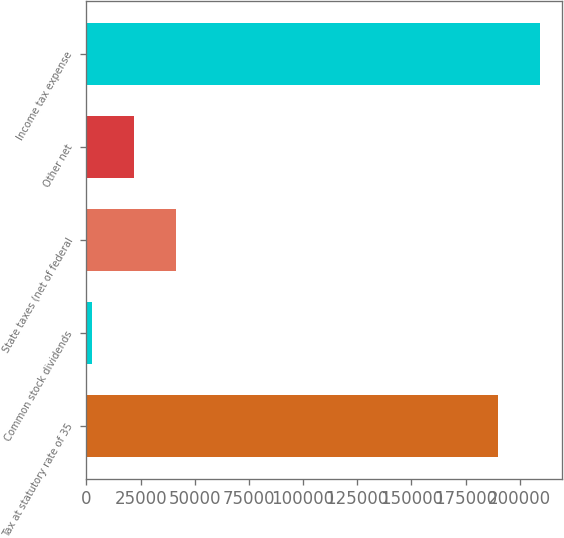Convert chart. <chart><loc_0><loc_0><loc_500><loc_500><bar_chart><fcel>Tax at statutory rate of 35<fcel>Common stock dividends<fcel>State taxes (net of federal<fcel>Other net<fcel>Income tax expense<nl><fcel>189764<fcel>2570<fcel>41384.4<fcel>21977.2<fcel>209171<nl></chart> 